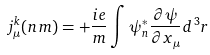<formula> <loc_0><loc_0><loc_500><loc_500>j _ { \mu } ^ { k } ( n \, m ) = + \frac { i e } { m } \int \psi ^ { * } _ { n } \frac { \partial \psi } { \partial x _ { \mu } } d ^ { \, 3 } r</formula> 